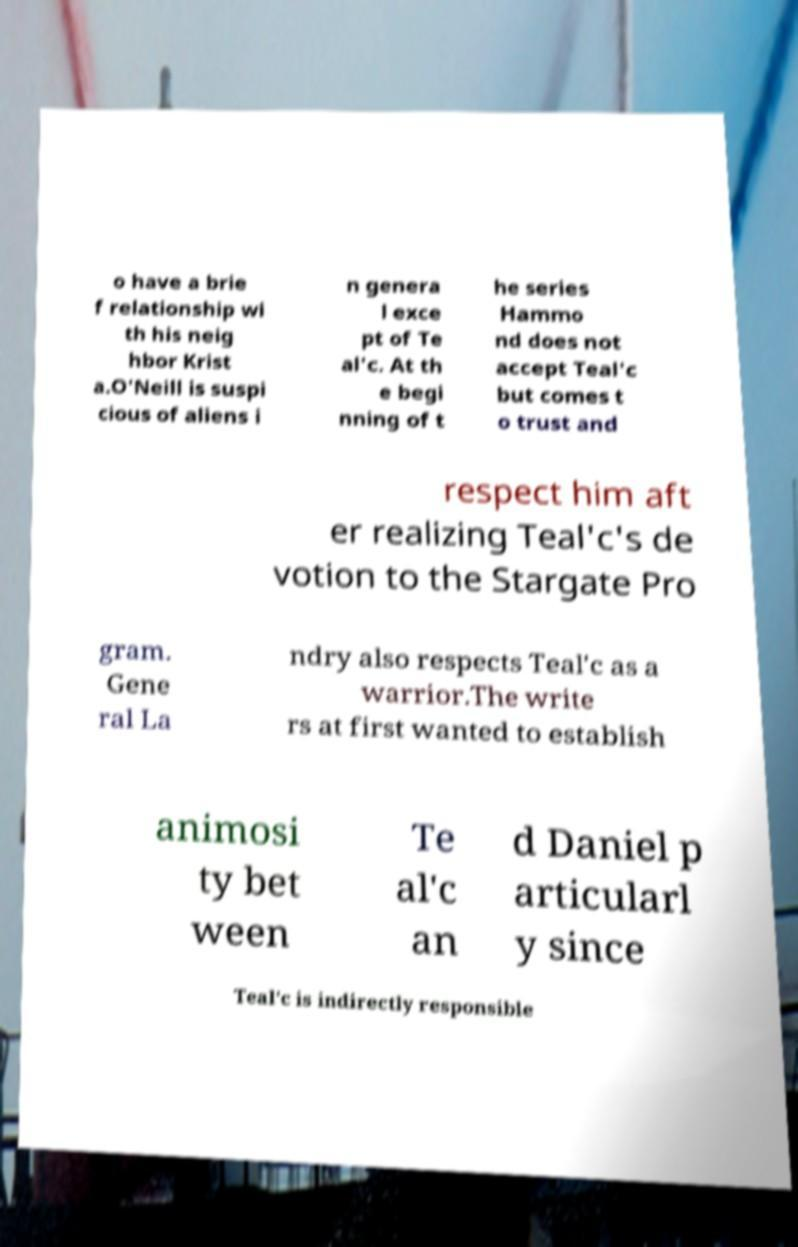Could you extract and type out the text from this image? o have a brie f relationship wi th his neig hbor Krist a.O'Neill is suspi cious of aliens i n genera l exce pt of Te al'c. At th e begi nning of t he series Hammo nd does not accept Teal'c but comes t o trust and respect him aft er realizing Teal'c's de votion to the Stargate Pro gram. Gene ral La ndry also respects Teal'c as a warrior.The write rs at first wanted to establish animosi ty bet ween Te al'c an d Daniel p articularl y since Teal'c is indirectly responsible 